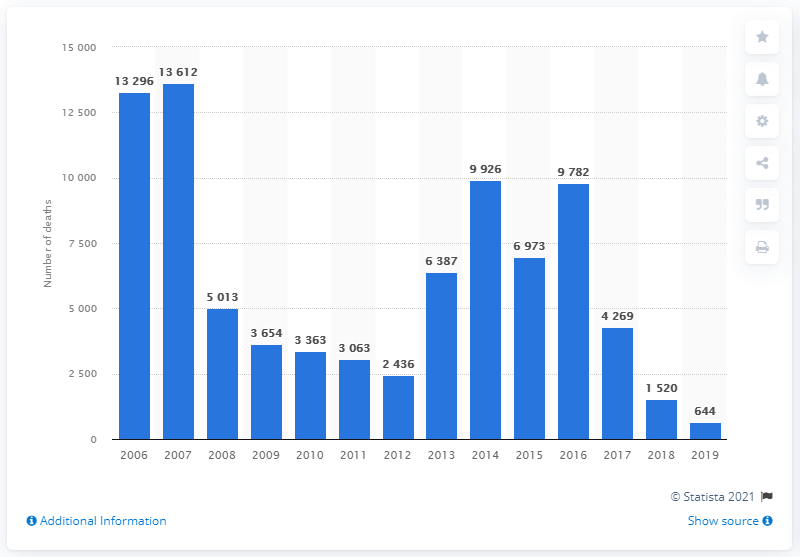Outline some significant characteristics in this image. In 2019, a total of 644 individuals were killed as a result of terrorist activities in Iraq. 